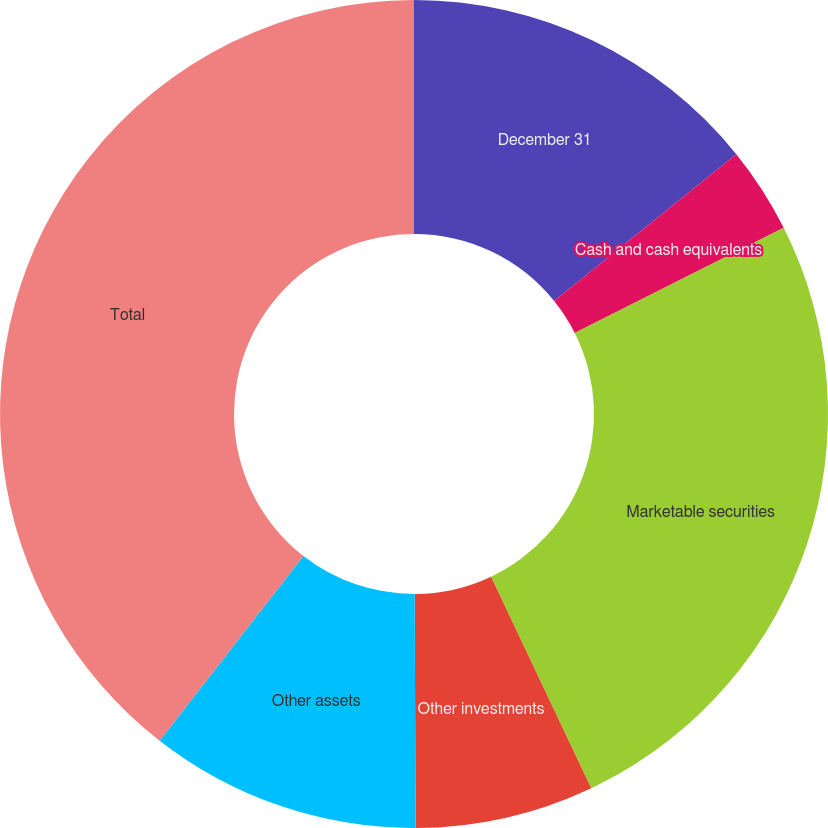Convert chart to OTSL. <chart><loc_0><loc_0><loc_500><loc_500><pie_chart><fcel>December 31<fcel>Cash and cash equivalents<fcel>Marketable securities<fcel>Other investments<fcel>Other assets<fcel>Total<nl><fcel>14.2%<fcel>3.37%<fcel>25.39%<fcel>6.98%<fcel>10.59%<fcel>39.47%<nl></chart> 